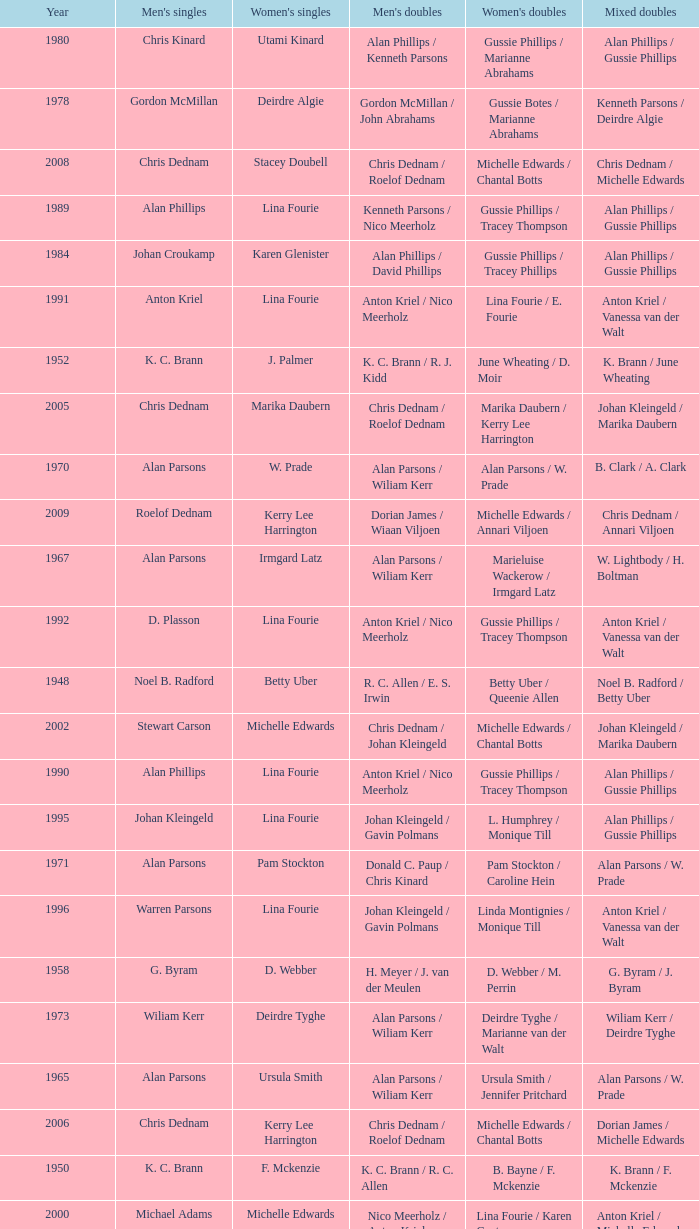Which Men's doubles have a Year smaller than 1960, and Men's singles of noel b. radford? R. C. Allen / E. S. Irwin. 